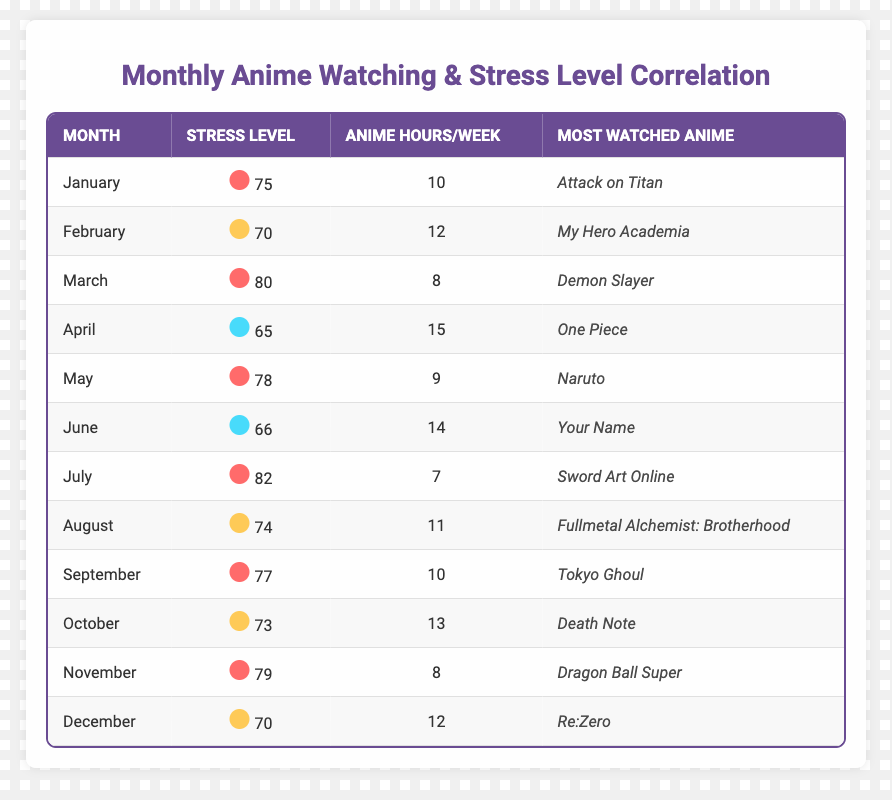What is the average stress level in June? The table lists June's average stress level as 66. Therefore, the answer is directly found in that row.
Answer: 66 Which month had the highest average stress level? By examining the stress levels listed for each month, July exhibits the highest stress level of 82.
Answer: July What is the most watched anime in April? The entry for April lists "One Piece" as the most watched anime.
Answer: One Piece How many anime watching hours per week were logged in March? Looking at the March entry, the average anime watching hours per week were 8 hours.
Answer: 8 What is the average stress level for the months with more than 10 anime watching hours per week? The months with more than 10 anime hours are February (70), April (65), June (66), August (74), October (73), and December (70). Their total stress levels sum to 70 + 65 + 66 + 74 + 73 + 70 = 418. There are 6 months, so the average is 418/6 = 69.67.
Answer: 69.67 Did the average stress level increase from May to July? Comparing the stress levels from these months: May (78), June (66), and July (82). May to June decreased (78 to 66), but June to July increased (66 to 82), showing an overall increase from May to July.
Answer: Yes Which month had the lowest anime watching hours per week? Inspecting the table, July had the lowest anime watching hours at 7 hours per week.
Answer: July What was the average stress level for the months with the most watched anime that are part of the 'Shonen' genre? In the data, the 'Shonen' anime listed are: "My Hero Academia" (February), "Naruto" (May), and "Dragon Ball Super" (November), with stress levels of 70, 78, and 79 respectively. Their total is 70 + 78 + 79 = 227 and the average is 227/3 = 75.67.
Answer: 75.67 Is there a correlation between the average anime watching hours per week and the average stress levels? Analyzing the provided data, instances showing high stress often correlate with fewer anime hours (e.g., July has 7 hours and high stress of 82). Therefore, it indicates an inverse correlation.
Answer: Yes What was the trend of average stress levels from January to December? Analyzing from January (75) down to April (65) shows a decline, then the pattern fluctuates slightly with peaks in March (80) and July (82) with an overall decrease afterward, closing at December (70).
Answer: Fluctuating with a slight decline overall 